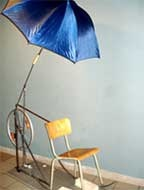Describe the objects in this image and their specific colors. I can see umbrella in darkgreen, lightblue, navy, and blue tones and chair in darkgreen, darkgray, khaki, and orange tones in this image. 